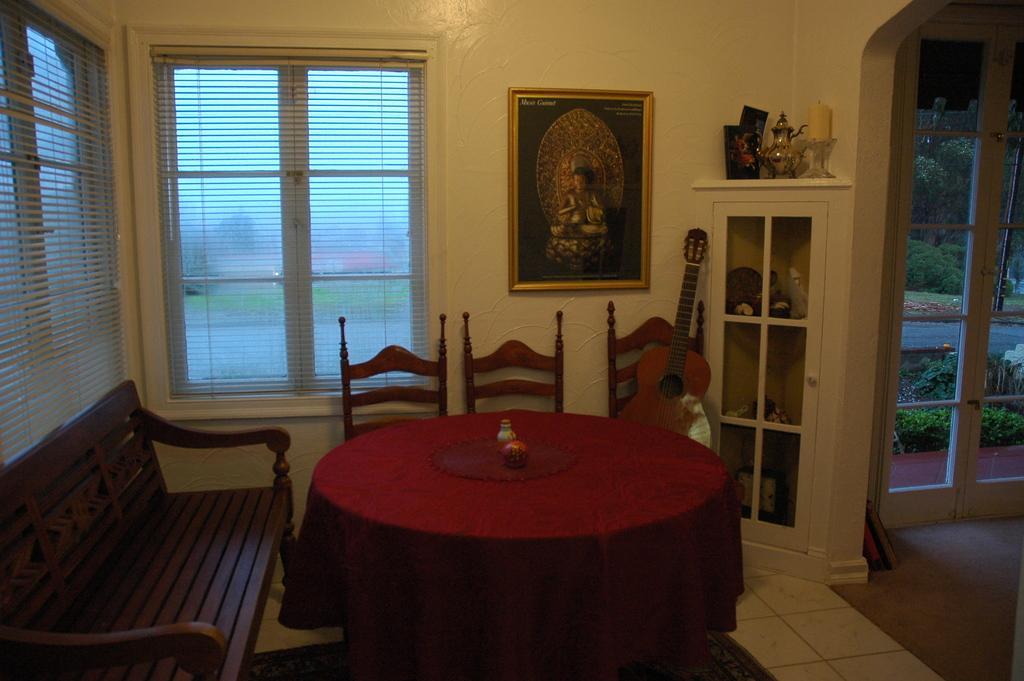Could you give a brief overview of what you see in this image? As we can see in the image there is a yellow color wall, window, photo frame, shelves, chairs and table. 